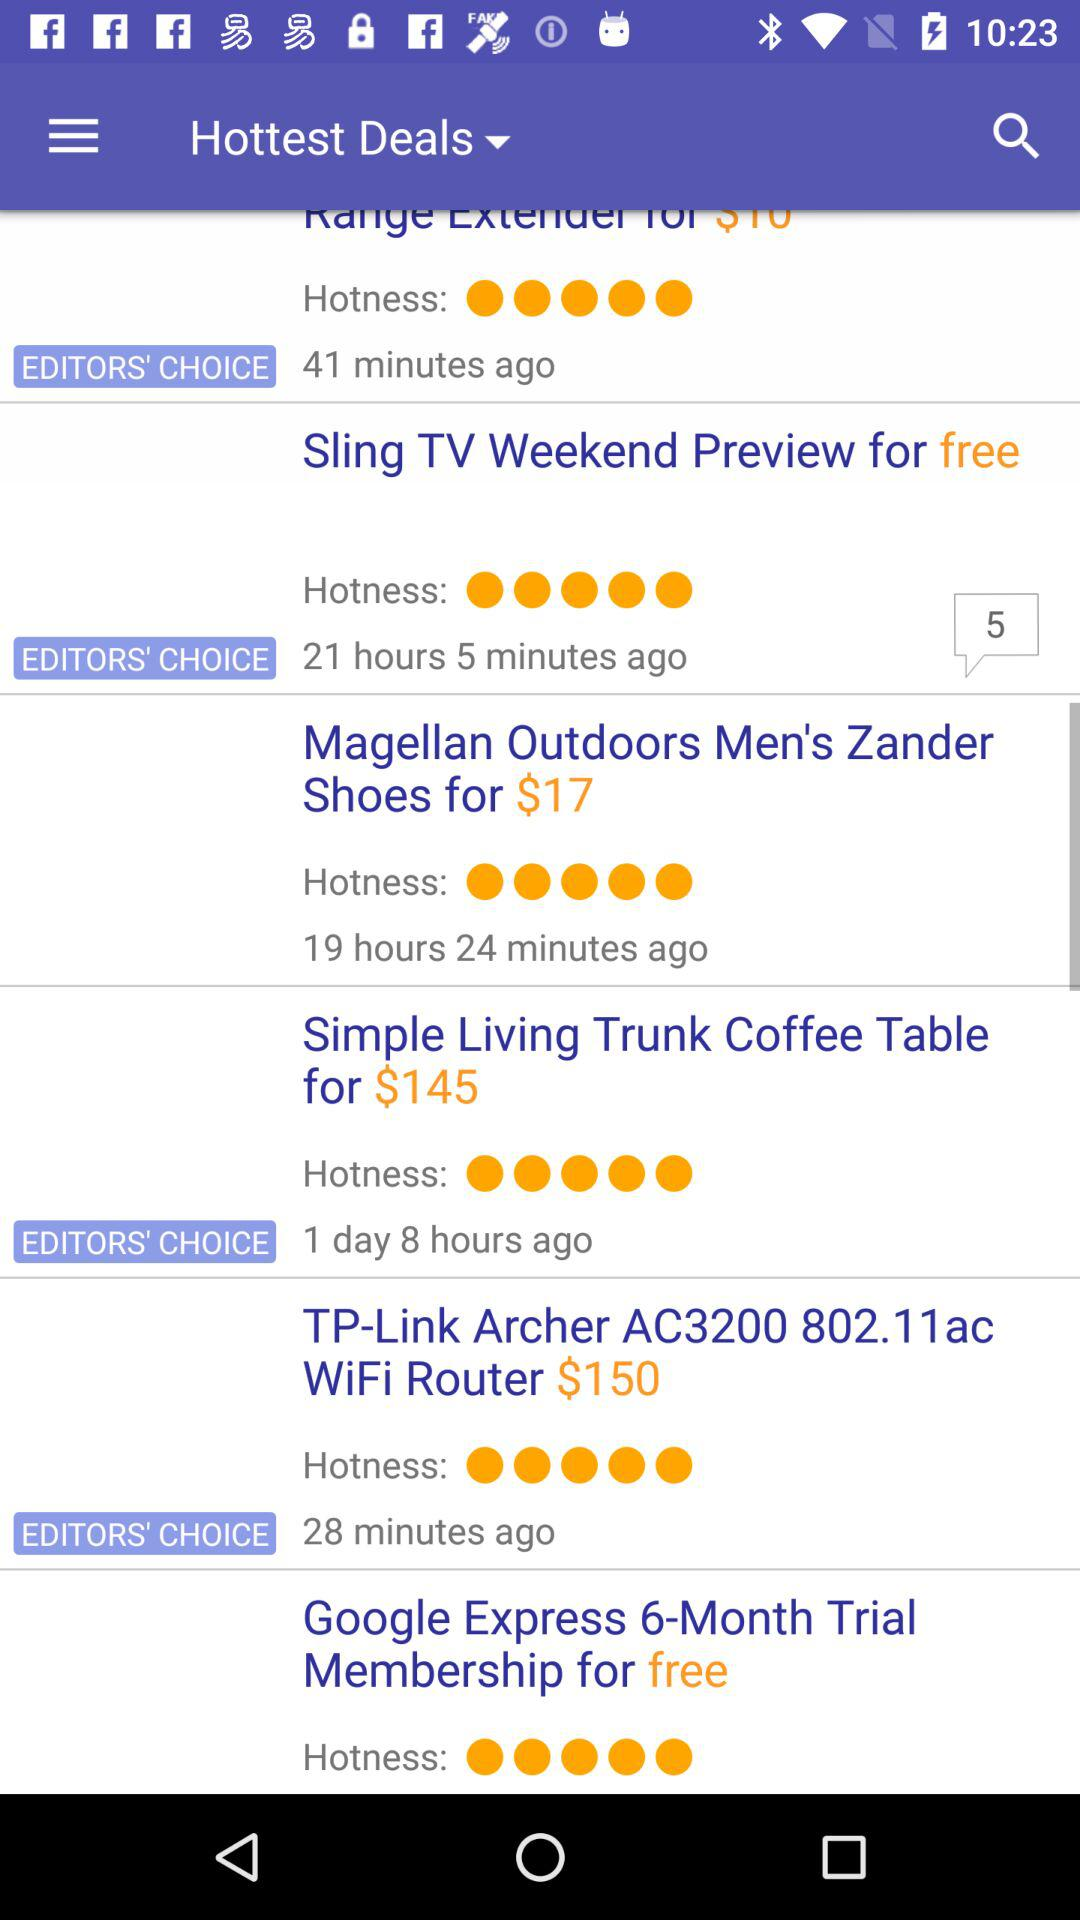What is the price of the "TP-Link Archer AC3200 802.11ac WiFi Router"? The price is $150. 